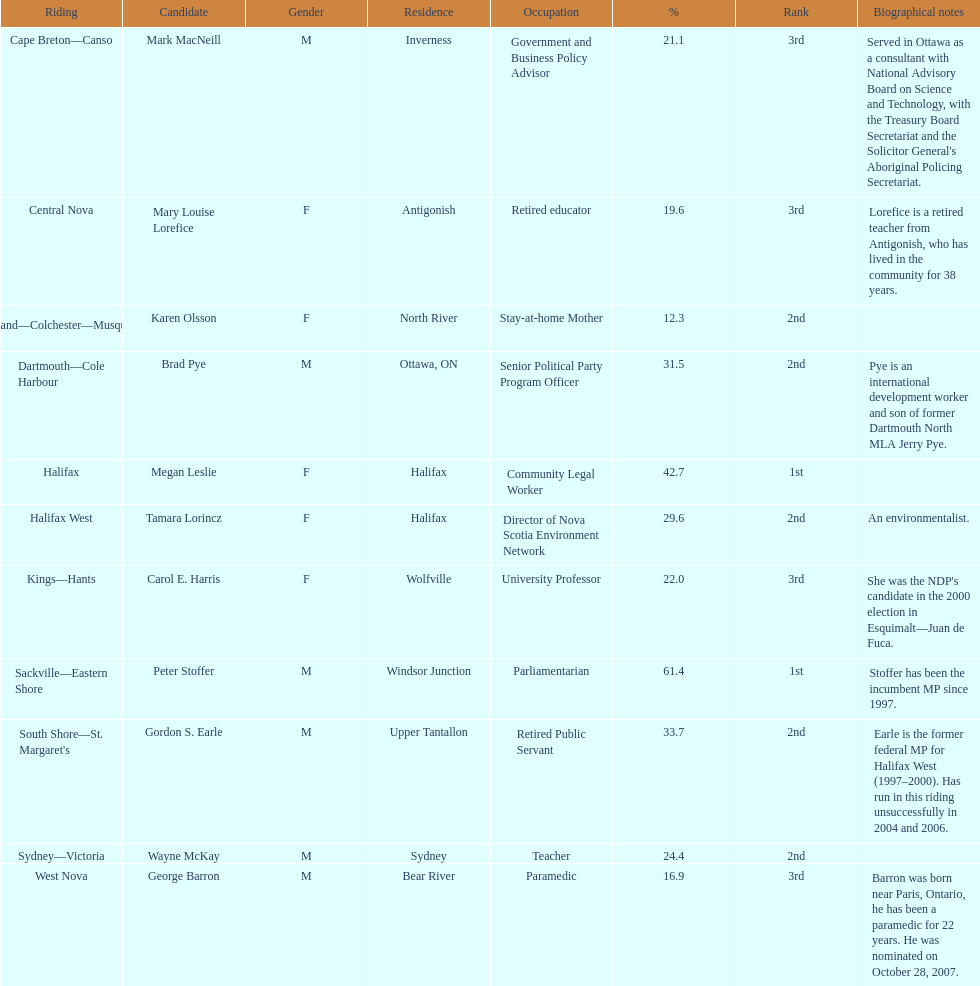Who has the greatest amount of votes? Sackville-Eastern Shore. 